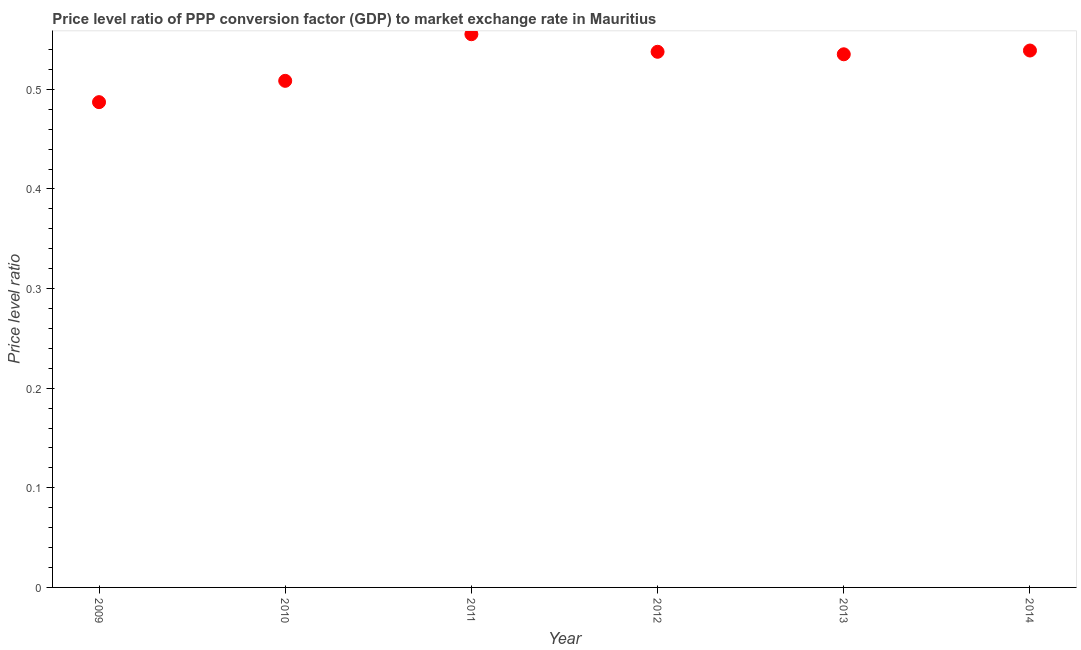What is the price level ratio in 2012?
Your answer should be very brief. 0.54. Across all years, what is the maximum price level ratio?
Your response must be concise. 0.56. Across all years, what is the minimum price level ratio?
Provide a succinct answer. 0.49. What is the sum of the price level ratio?
Ensure brevity in your answer.  3.16. What is the difference between the price level ratio in 2011 and 2012?
Offer a terse response. 0.02. What is the average price level ratio per year?
Offer a terse response. 0.53. What is the median price level ratio?
Your answer should be very brief. 0.54. In how many years, is the price level ratio greater than 0.18 ?
Provide a short and direct response. 6. Do a majority of the years between 2012 and 2014 (inclusive) have price level ratio greater than 0.42000000000000004 ?
Offer a terse response. Yes. What is the ratio of the price level ratio in 2010 to that in 2011?
Offer a terse response. 0.92. Is the price level ratio in 2010 less than that in 2012?
Provide a short and direct response. Yes. What is the difference between the highest and the second highest price level ratio?
Give a very brief answer. 0.02. Is the sum of the price level ratio in 2010 and 2011 greater than the maximum price level ratio across all years?
Make the answer very short. Yes. What is the difference between the highest and the lowest price level ratio?
Your response must be concise. 0.07. In how many years, is the price level ratio greater than the average price level ratio taken over all years?
Offer a very short reply. 4. What is the difference between two consecutive major ticks on the Y-axis?
Provide a short and direct response. 0.1. Does the graph contain any zero values?
Your response must be concise. No. Does the graph contain grids?
Give a very brief answer. No. What is the title of the graph?
Provide a succinct answer. Price level ratio of PPP conversion factor (GDP) to market exchange rate in Mauritius. What is the label or title of the Y-axis?
Provide a succinct answer. Price level ratio. What is the Price level ratio in 2009?
Keep it short and to the point. 0.49. What is the Price level ratio in 2010?
Offer a very short reply. 0.51. What is the Price level ratio in 2011?
Provide a short and direct response. 0.56. What is the Price level ratio in 2012?
Your answer should be compact. 0.54. What is the Price level ratio in 2013?
Keep it short and to the point. 0.54. What is the Price level ratio in 2014?
Offer a very short reply. 0.54. What is the difference between the Price level ratio in 2009 and 2010?
Your answer should be very brief. -0.02. What is the difference between the Price level ratio in 2009 and 2011?
Your answer should be very brief. -0.07. What is the difference between the Price level ratio in 2009 and 2012?
Keep it short and to the point. -0.05. What is the difference between the Price level ratio in 2009 and 2013?
Keep it short and to the point. -0.05. What is the difference between the Price level ratio in 2009 and 2014?
Offer a terse response. -0.05. What is the difference between the Price level ratio in 2010 and 2011?
Give a very brief answer. -0.05. What is the difference between the Price level ratio in 2010 and 2012?
Your answer should be very brief. -0.03. What is the difference between the Price level ratio in 2010 and 2013?
Provide a short and direct response. -0.03. What is the difference between the Price level ratio in 2010 and 2014?
Give a very brief answer. -0.03. What is the difference between the Price level ratio in 2011 and 2012?
Ensure brevity in your answer.  0.02. What is the difference between the Price level ratio in 2011 and 2013?
Provide a succinct answer. 0.02. What is the difference between the Price level ratio in 2011 and 2014?
Give a very brief answer. 0.02. What is the difference between the Price level ratio in 2012 and 2013?
Your answer should be very brief. 0. What is the difference between the Price level ratio in 2012 and 2014?
Keep it short and to the point. -0. What is the difference between the Price level ratio in 2013 and 2014?
Offer a terse response. -0. What is the ratio of the Price level ratio in 2009 to that in 2010?
Keep it short and to the point. 0.96. What is the ratio of the Price level ratio in 2009 to that in 2011?
Provide a succinct answer. 0.88. What is the ratio of the Price level ratio in 2009 to that in 2012?
Provide a succinct answer. 0.91. What is the ratio of the Price level ratio in 2009 to that in 2013?
Your answer should be compact. 0.91. What is the ratio of the Price level ratio in 2009 to that in 2014?
Your response must be concise. 0.9. What is the ratio of the Price level ratio in 2010 to that in 2011?
Provide a short and direct response. 0.92. What is the ratio of the Price level ratio in 2010 to that in 2012?
Provide a succinct answer. 0.95. What is the ratio of the Price level ratio in 2010 to that in 2013?
Offer a terse response. 0.95. What is the ratio of the Price level ratio in 2010 to that in 2014?
Your response must be concise. 0.94. What is the ratio of the Price level ratio in 2011 to that in 2012?
Offer a terse response. 1.03. What is the ratio of the Price level ratio in 2011 to that in 2013?
Keep it short and to the point. 1.04. What is the ratio of the Price level ratio in 2011 to that in 2014?
Give a very brief answer. 1.03. 